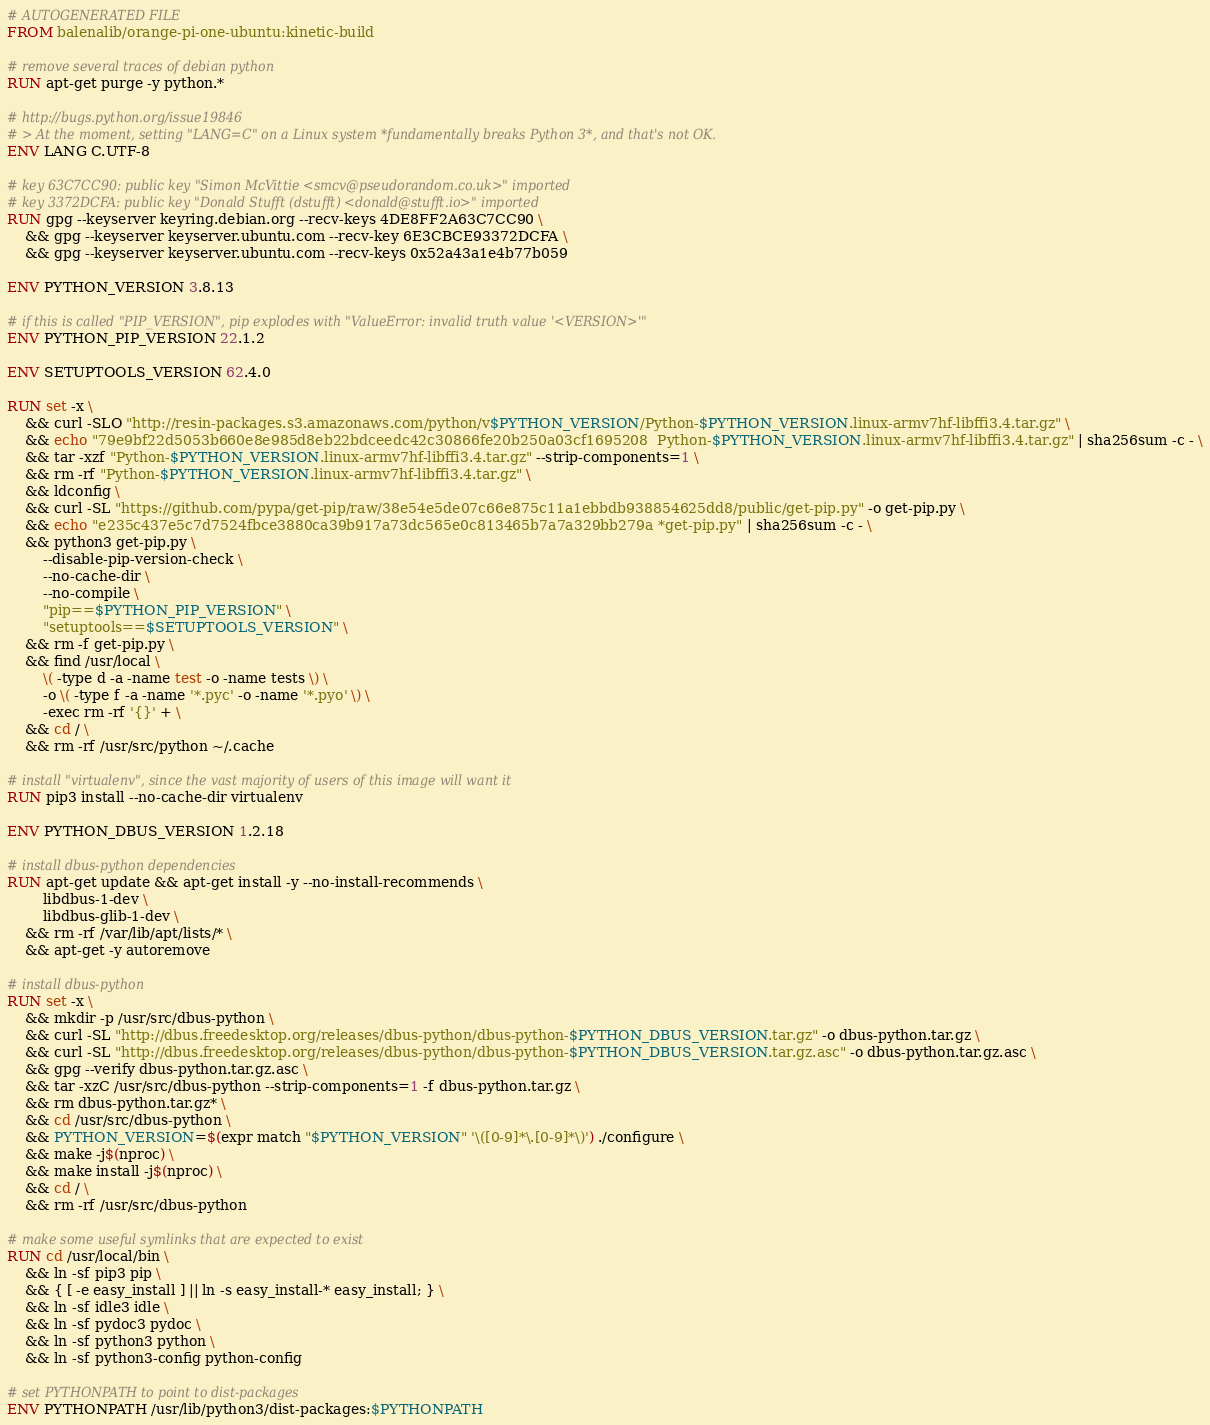Convert code to text. <code><loc_0><loc_0><loc_500><loc_500><_Dockerfile_># AUTOGENERATED FILE
FROM balenalib/orange-pi-one-ubuntu:kinetic-build

# remove several traces of debian python
RUN apt-get purge -y python.*

# http://bugs.python.org/issue19846
# > At the moment, setting "LANG=C" on a Linux system *fundamentally breaks Python 3*, and that's not OK.
ENV LANG C.UTF-8

# key 63C7CC90: public key "Simon McVittie <smcv@pseudorandom.co.uk>" imported
# key 3372DCFA: public key "Donald Stufft (dstufft) <donald@stufft.io>" imported
RUN gpg --keyserver keyring.debian.org --recv-keys 4DE8FF2A63C7CC90 \
	&& gpg --keyserver keyserver.ubuntu.com --recv-key 6E3CBCE93372DCFA \
	&& gpg --keyserver keyserver.ubuntu.com --recv-keys 0x52a43a1e4b77b059

ENV PYTHON_VERSION 3.8.13

# if this is called "PIP_VERSION", pip explodes with "ValueError: invalid truth value '<VERSION>'"
ENV PYTHON_PIP_VERSION 22.1.2

ENV SETUPTOOLS_VERSION 62.4.0

RUN set -x \
	&& curl -SLO "http://resin-packages.s3.amazonaws.com/python/v$PYTHON_VERSION/Python-$PYTHON_VERSION.linux-armv7hf-libffi3.4.tar.gz" \
	&& echo "79e9bf22d5053b660e8e985d8eb22bdceedc42c30866fe20b250a03cf1695208  Python-$PYTHON_VERSION.linux-armv7hf-libffi3.4.tar.gz" | sha256sum -c - \
	&& tar -xzf "Python-$PYTHON_VERSION.linux-armv7hf-libffi3.4.tar.gz" --strip-components=1 \
	&& rm -rf "Python-$PYTHON_VERSION.linux-armv7hf-libffi3.4.tar.gz" \
	&& ldconfig \
	&& curl -SL "https://github.com/pypa/get-pip/raw/38e54e5de07c66e875c11a1ebbdb938854625dd8/public/get-pip.py" -o get-pip.py \
    && echo "e235c437e5c7d7524fbce3880ca39b917a73dc565e0c813465b7a7a329bb279a *get-pip.py" | sha256sum -c - \
    && python3 get-pip.py \
        --disable-pip-version-check \
        --no-cache-dir \
        --no-compile \
        "pip==$PYTHON_PIP_VERSION" \
        "setuptools==$SETUPTOOLS_VERSION" \
	&& rm -f get-pip.py \
	&& find /usr/local \
		\( -type d -a -name test -o -name tests \) \
		-o \( -type f -a -name '*.pyc' -o -name '*.pyo' \) \
		-exec rm -rf '{}' + \
	&& cd / \
	&& rm -rf /usr/src/python ~/.cache

# install "virtualenv", since the vast majority of users of this image will want it
RUN pip3 install --no-cache-dir virtualenv

ENV PYTHON_DBUS_VERSION 1.2.18

# install dbus-python dependencies 
RUN apt-get update && apt-get install -y --no-install-recommends \
		libdbus-1-dev \
		libdbus-glib-1-dev \
	&& rm -rf /var/lib/apt/lists/* \
	&& apt-get -y autoremove

# install dbus-python
RUN set -x \
	&& mkdir -p /usr/src/dbus-python \
	&& curl -SL "http://dbus.freedesktop.org/releases/dbus-python/dbus-python-$PYTHON_DBUS_VERSION.tar.gz" -o dbus-python.tar.gz \
	&& curl -SL "http://dbus.freedesktop.org/releases/dbus-python/dbus-python-$PYTHON_DBUS_VERSION.tar.gz.asc" -o dbus-python.tar.gz.asc \
	&& gpg --verify dbus-python.tar.gz.asc \
	&& tar -xzC /usr/src/dbus-python --strip-components=1 -f dbus-python.tar.gz \
	&& rm dbus-python.tar.gz* \
	&& cd /usr/src/dbus-python \
	&& PYTHON_VERSION=$(expr match "$PYTHON_VERSION" '\([0-9]*\.[0-9]*\)') ./configure \
	&& make -j$(nproc) \
	&& make install -j$(nproc) \
	&& cd / \
	&& rm -rf /usr/src/dbus-python

# make some useful symlinks that are expected to exist
RUN cd /usr/local/bin \
	&& ln -sf pip3 pip \
	&& { [ -e easy_install ] || ln -s easy_install-* easy_install; } \
	&& ln -sf idle3 idle \
	&& ln -sf pydoc3 pydoc \
	&& ln -sf python3 python \
	&& ln -sf python3-config python-config

# set PYTHONPATH to point to dist-packages
ENV PYTHONPATH /usr/lib/python3/dist-packages:$PYTHONPATH
</code> 